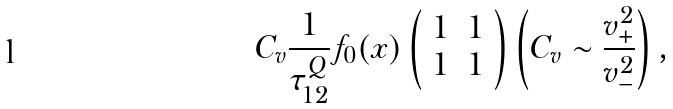<formula> <loc_0><loc_0><loc_500><loc_500>C _ { v } \frac { 1 } { \tau _ { 1 2 } ^ { Q } } f _ { 0 } ( x ) \left ( \begin{array} { c c } 1 & 1 \\ 1 & 1 \end{array} \right ) \left ( C _ { v } \sim \frac { v _ { + } ^ { 2 } } { v _ { - } ^ { 2 } } \right ) ,</formula> 